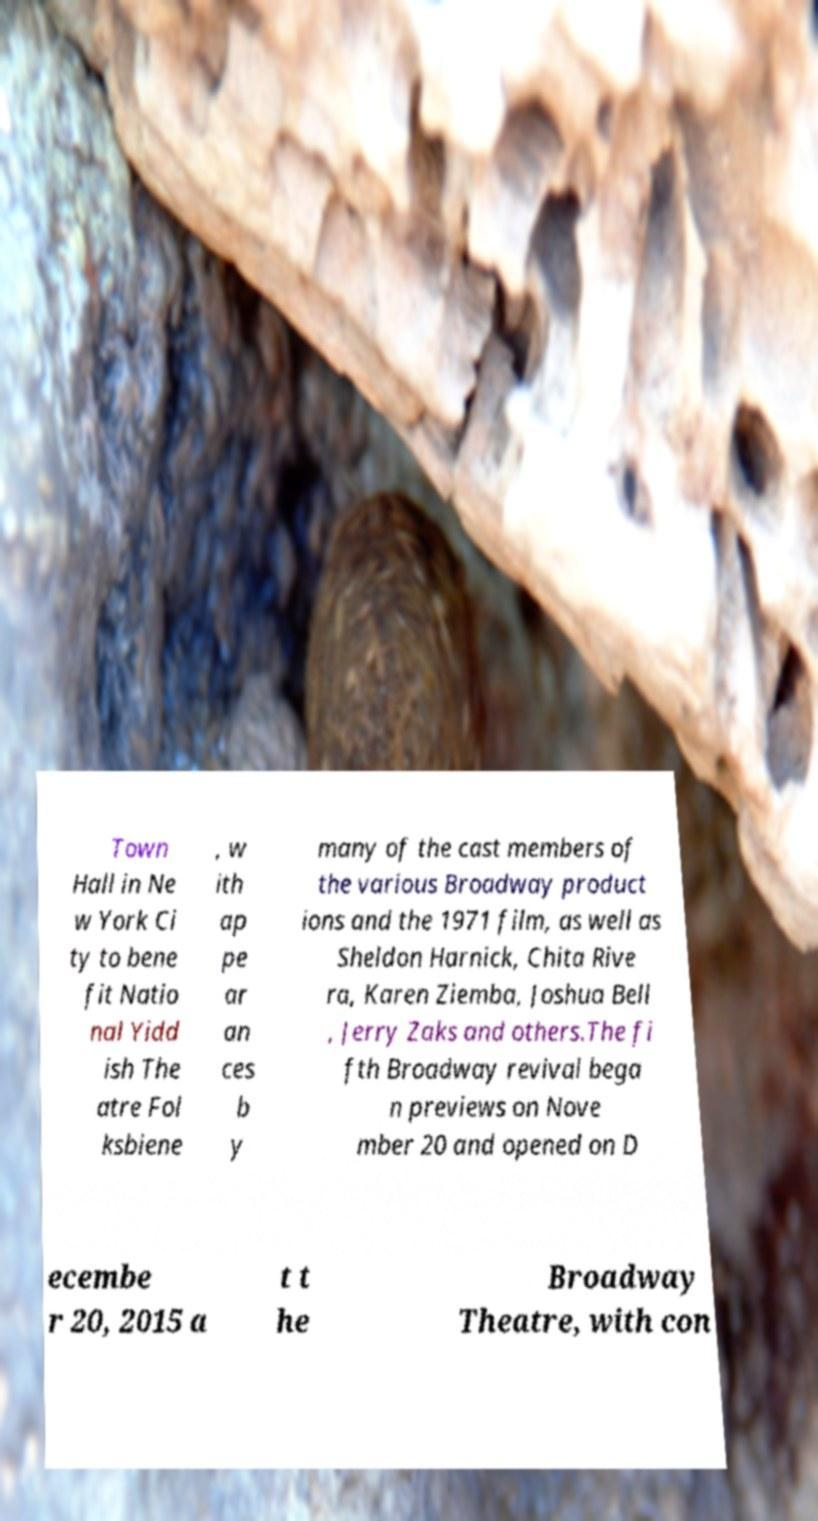Could you extract and type out the text from this image? Town Hall in Ne w York Ci ty to bene fit Natio nal Yidd ish The atre Fol ksbiene , w ith ap pe ar an ces b y many of the cast members of the various Broadway product ions and the 1971 film, as well as Sheldon Harnick, Chita Rive ra, Karen Ziemba, Joshua Bell , Jerry Zaks and others.The fi fth Broadway revival bega n previews on Nove mber 20 and opened on D ecembe r 20, 2015 a t t he Broadway Theatre, with con 